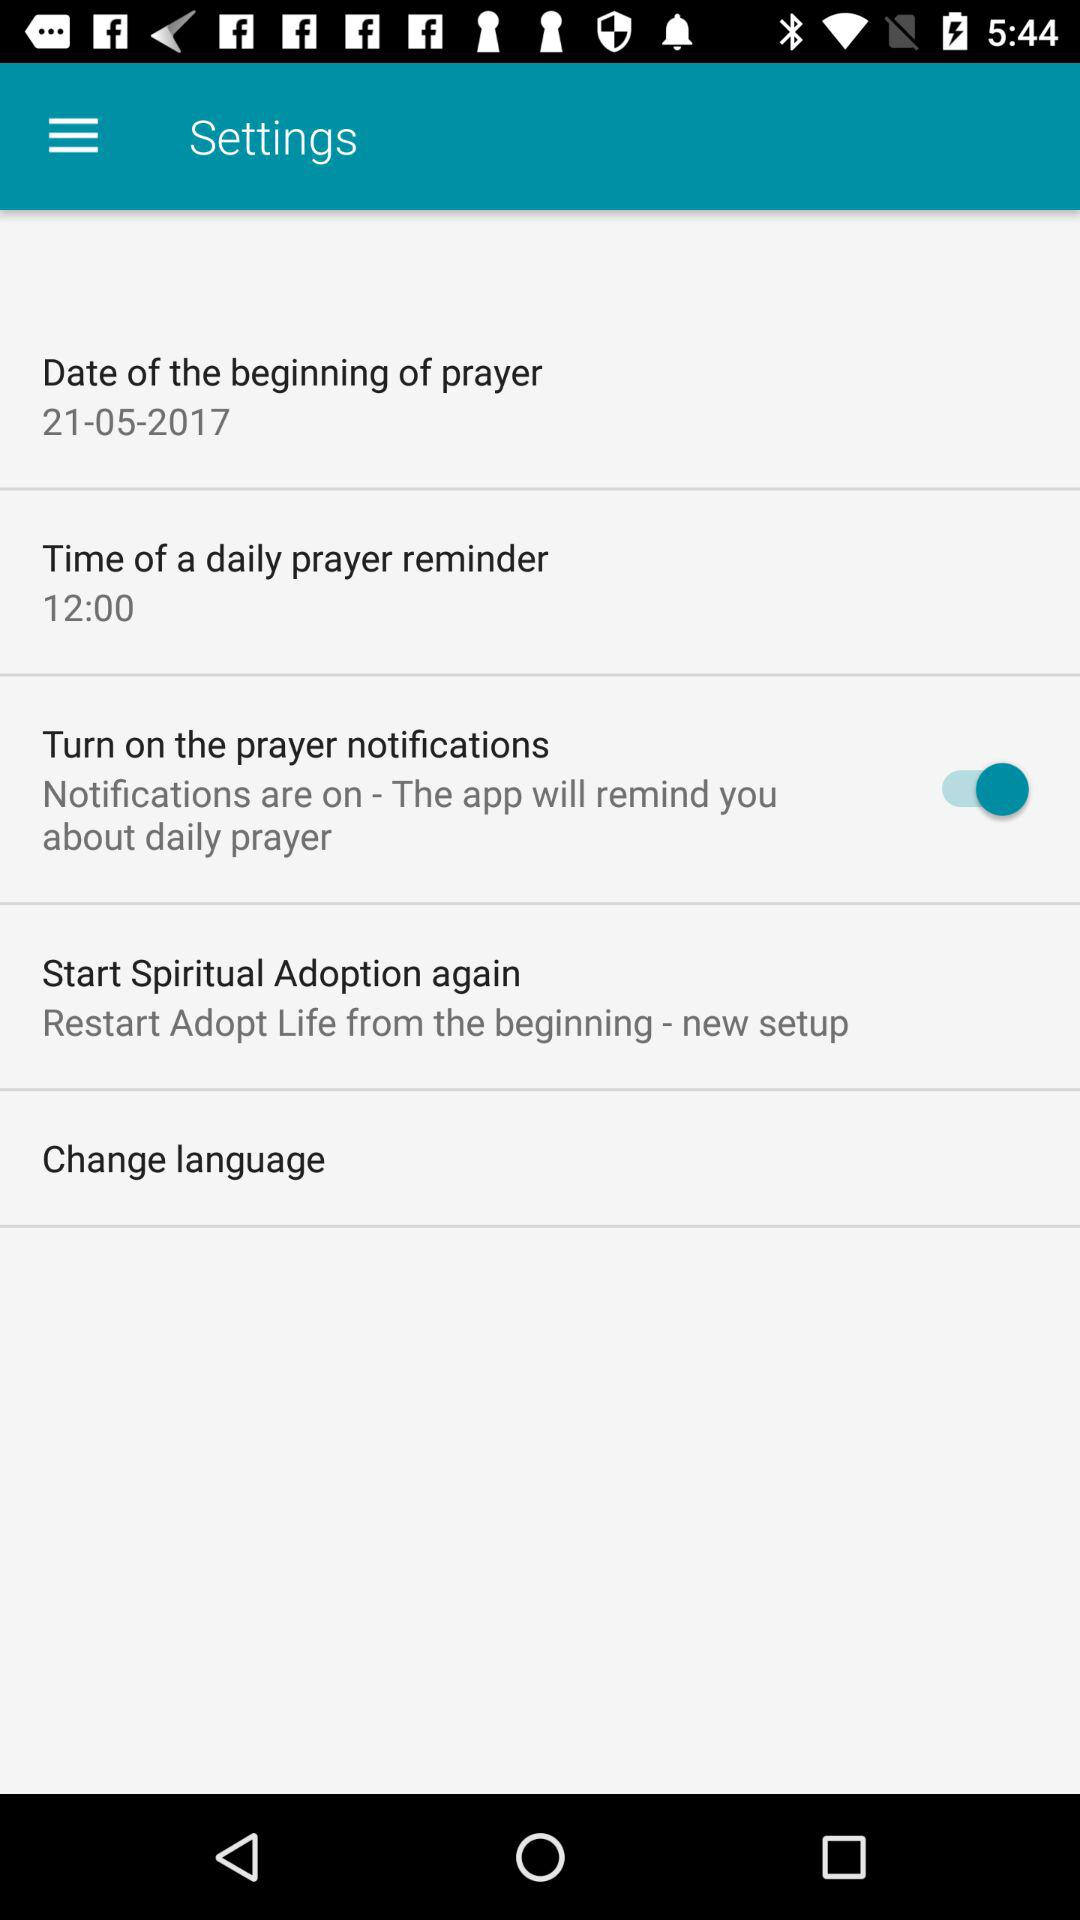What is the time of the daily prayer reminder? The time is 12:00. 